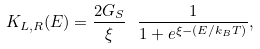<formula> <loc_0><loc_0><loc_500><loc_500>K _ { L , R } ( E ) = \frac { 2 G _ { S } } { \xi } \ \frac { 1 } { 1 + e ^ { \xi - ( E / k _ { B } T ) } } ,</formula> 